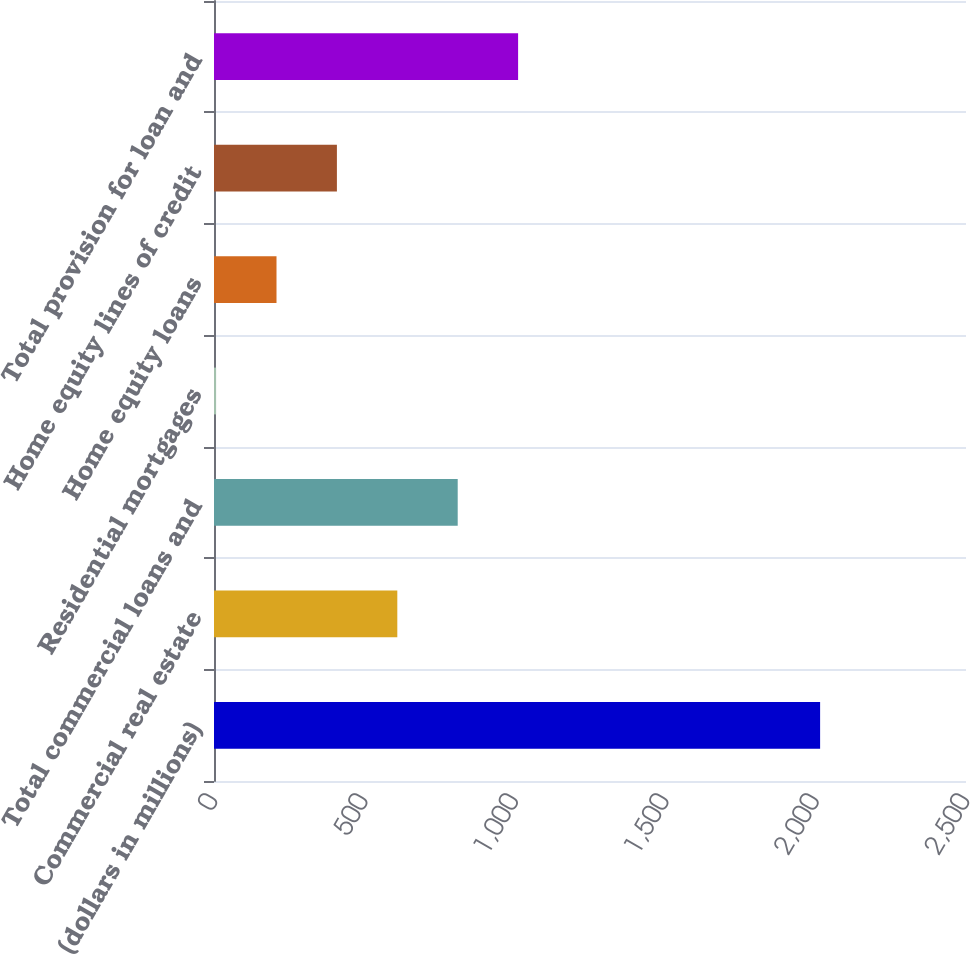Convert chart. <chart><loc_0><loc_0><loc_500><loc_500><bar_chart><fcel>(dollars in millions)<fcel>Commercial real estate<fcel>Total commercial loans and<fcel>Residential mortgages<fcel>Home equity loans<fcel>Home equity lines of credit<fcel>Total provision for loan and<nl><fcel>2015<fcel>609.4<fcel>810.2<fcel>7<fcel>207.8<fcel>408.6<fcel>1011<nl></chart> 